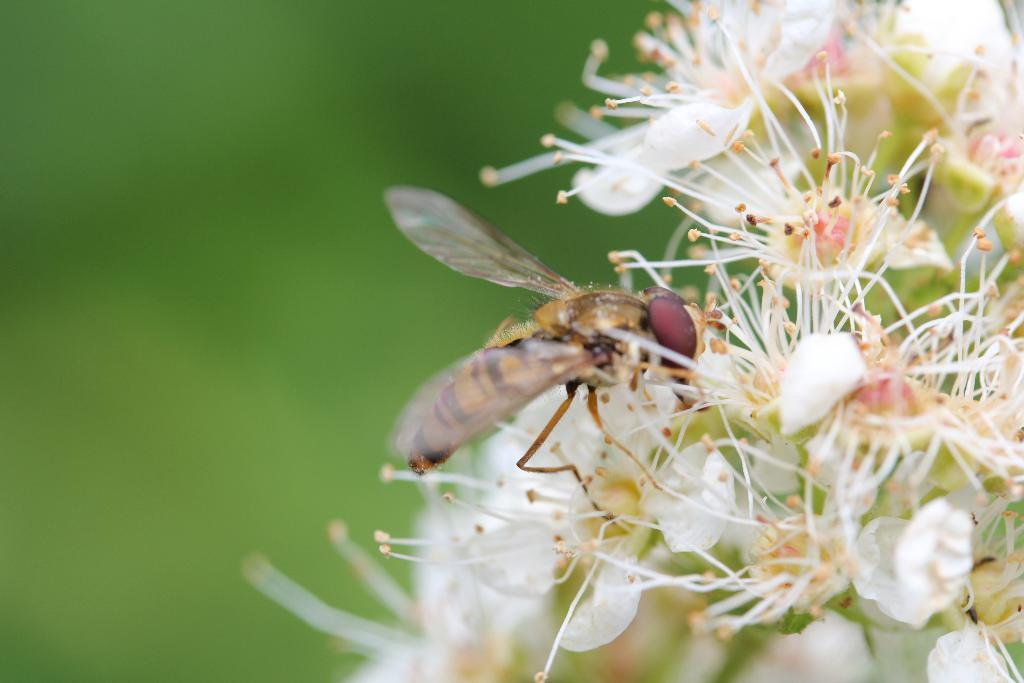What type of flowers are on the right side of the image? There are white color flowers on the right side of the image. Are there any insects present in the image? Yes, there is a fly on the flowers. How would you describe the background of the image? The background of the image is blurred. What is the son doing with the bucket in the image? There is no son or bucket present in the image. 